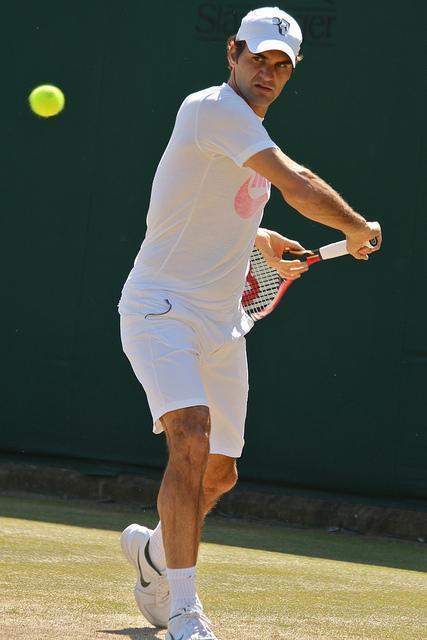How many towers have clocks on them?
Give a very brief answer. 0. 